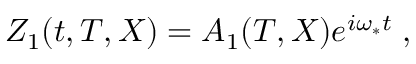Convert formula to latex. <formula><loc_0><loc_0><loc_500><loc_500>Z _ { 1 } ( t , T , X ) = A _ { 1 } ( T , X ) e ^ { i \omega _ { * } t } \, ,</formula> 